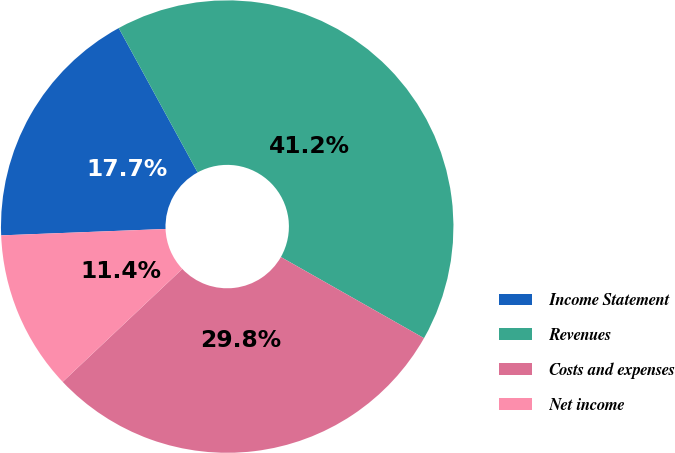Convert chart. <chart><loc_0><loc_0><loc_500><loc_500><pie_chart><fcel>Income Statement<fcel>Revenues<fcel>Costs and expenses<fcel>Net income<nl><fcel>17.66%<fcel>41.17%<fcel>29.75%<fcel>11.42%<nl></chart> 